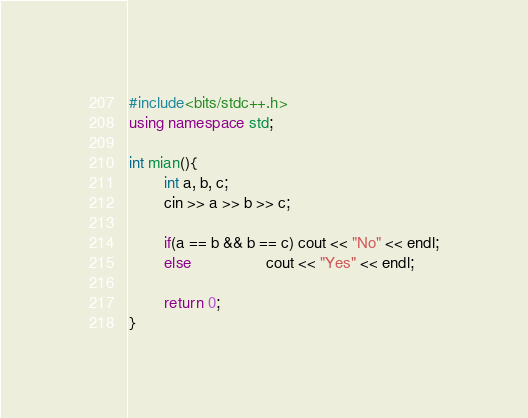Convert code to text. <code><loc_0><loc_0><loc_500><loc_500><_C++_>#include<bits/stdc++.h>
using namespace std;

int mian(){
        int a, b, c;
        cin >> a >> b >> c;

        if(a == b && b == c) cout << "No" << endl;
        else                 cout << "Yes" << endl;

        return 0;
}   </code> 